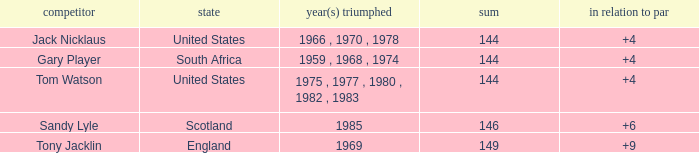What was Tom Watson's lowest To par when the total was larger than 144? None. 